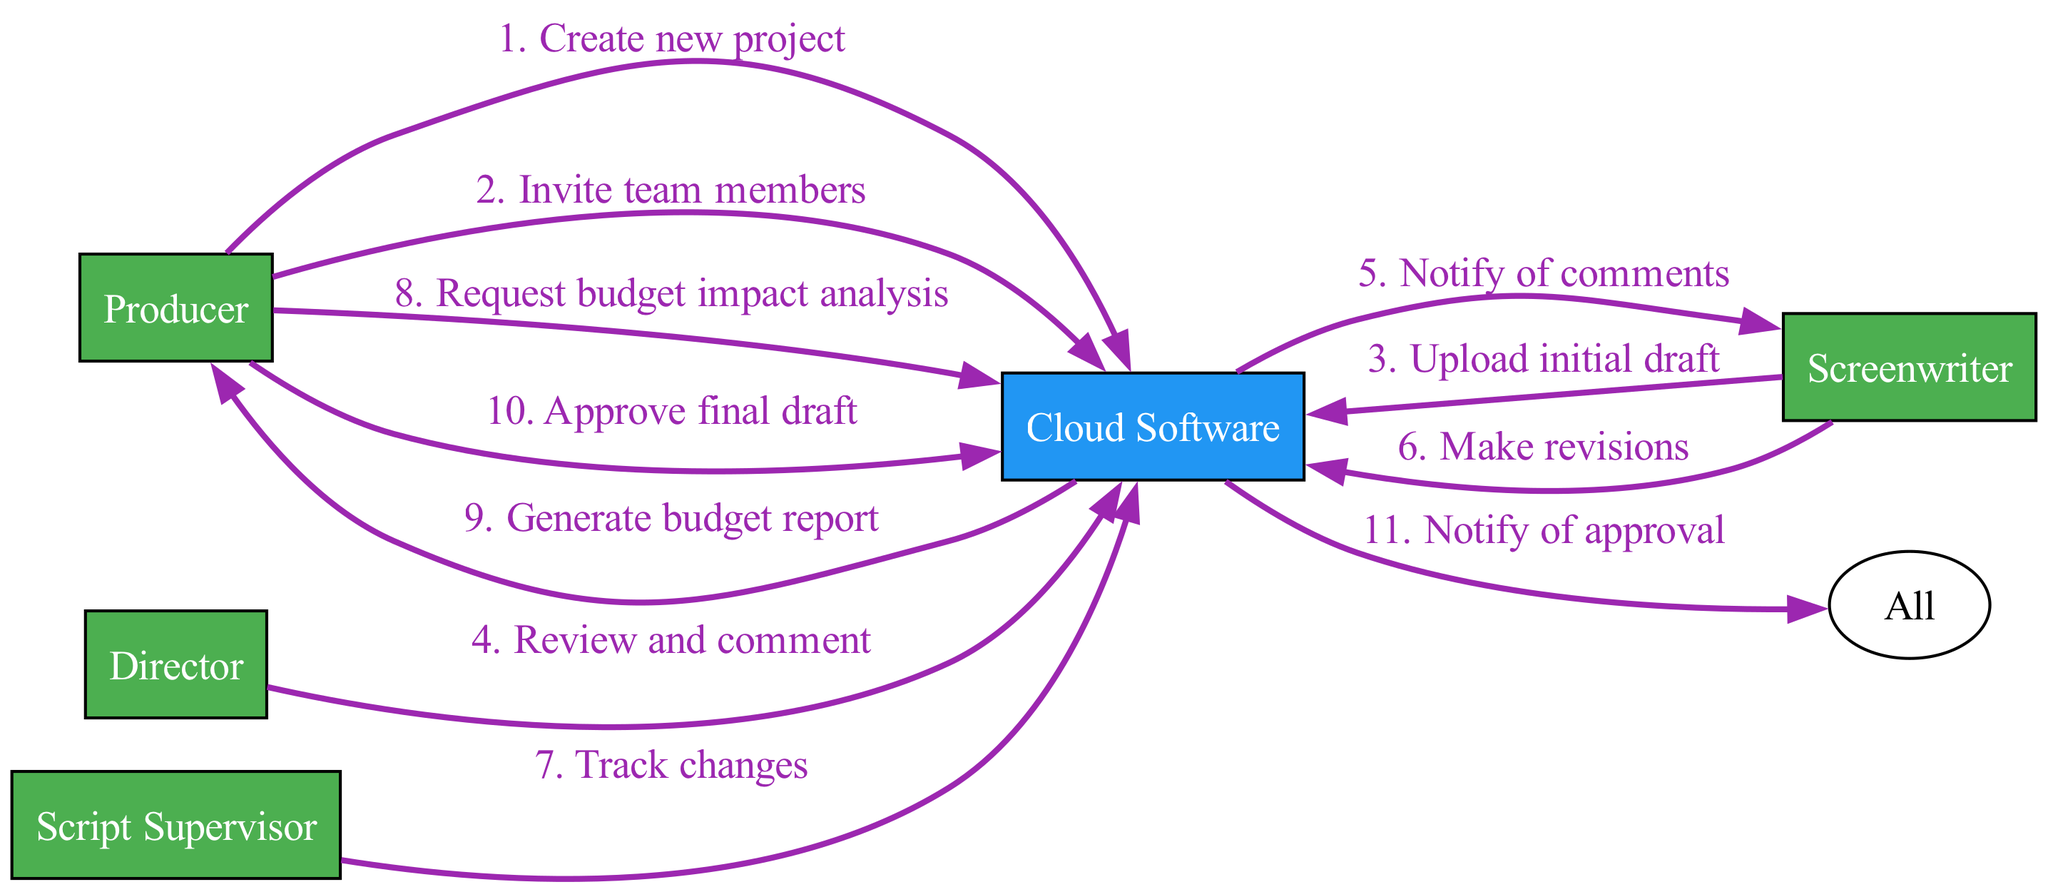What is the first action in the sequence? The diagram shows that the first action occurs from the Producer to the Cloud Software with the action labeled "Create new project". This is the first position in the sequence listed.
Answer: Create new project How many actors are involved in the process? By counting the unique actors listed in the diagram, we find there are five actors: Producer, Director, Screenwriter, Script Supervisor, and Cloud Software.
Answer: Five Which actor uploads the initial draft? The sequence indicates that the Screenwriter is the actor responsible for uploading the initial draft to the Cloud Software, as noted in the corresponding action.
Answer: Screenwriter What action follows after the Director's review? After the Director reviews and comments on the screenplay, the next action that follows is the Cloud Software notifying the Screenwriter of the comments made, according to the sequence flow.
Answer: Notify of comments Who receives the budget report after the request? According to the sequence, after the Producer requests a budget impact analysis, the Cloud Software generates a budget report and sends it to the Producer, completing that action chain.
Answer: Producer Which action occurs before the approval of the final draft? The action that occurs just before the approval of the final draft is when the Cloud Software notifies all team members about the approval, indicating that this is the last step in the approval process.
Answer: Notify of approval How many actions are taken by the Producer in the process? By examining the sequence, we find that the Producer takes three actions: creating a new project, inviting team members, and approving the final draft, which counts as three distinct actions performed by this actor.
Answer: Three What is the last action in the sequence? The final action in the sequence is labeled "Notify of approval", which is done by the Cloud Software to all actors involved, marking the end of the collaborative process.
Answer: Notify of approval What does the Script Supervisor do in this process? The Script Supervisor tracks changes as represented by the action directed towards the Cloud Software, which illustrates their role in monitoring revisions during the screenplay development process.
Answer: Track changes 